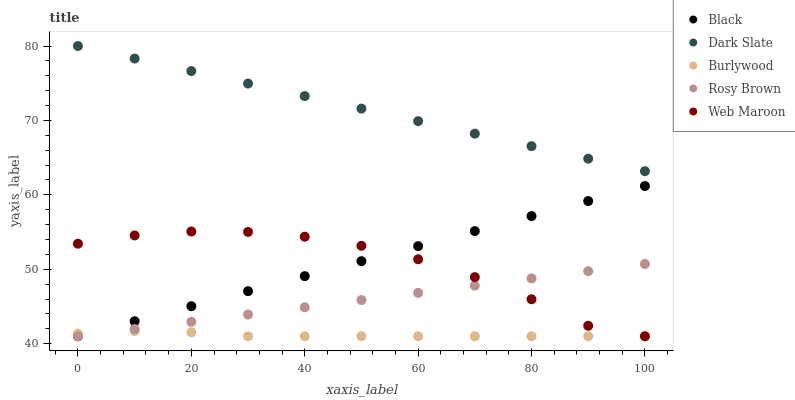Does Burlywood have the minimum area under the curve?
Answer yes or no. Yes. Does Dark Slate have the maximum area under the curve?
Answer yes or no. Yes. Does Rosy Brown have the minimum area under the curve?
Answer yes or no. No. Does Rosy Brown have the maximum area under the curve?
Answer yes or no. No. Is Dark Slate the smoothest?
Answer yes or no. Yes. Is Web Maroon the roughest?
Answer yes or no. Yes. Is Black the smoothest?
Answer yes or no. No. Is Black the roughest?
Answer yes or no. No. Does Burlywood have the lowest value?
Answer yes or no. Yes. Does Dark Slate have the lowest value?
Answer yes or no. No. Does Dark Slate have the highest value?
Answer yes or no. Yes. Does Rosy Brown have the highest value?
Answer yes or no. No. Is Web Maroon less than Dark Slate?
Answer yes or no. Yes. Is Dark Slate greater than Burlywood?
Answer yes or no. Yes. Does Black intersect Web Maroon?
Answer yes or no. Yes. Is Black less than Web Maroon?
Answer yes or no. No. Is Black greater than Web Maroon?
Answer yes or no. No. Does Web Maroon intersect Dark Slate?
Answer yes or no. No. 